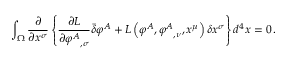<formula> <loc_0><loc_0><loc_500><loc_500>\int _ { \Omega } { \frac { \partial } { \partial x ^ { \sigma } } } \left \{ { \frac { \partial L } { \partial { \varphi ^ { A } } _ { , \sigma } } } { \bar { \delta } } \varphi ^ { A } + L \left ( \varphi ^ { A } , { \varphi ^ { A } } _ { , \nu } , x ^ { \mu } \right ) \delta x ^ { \sigma } \right \} d ^ { 4 } x = 0 \, .</formula> 